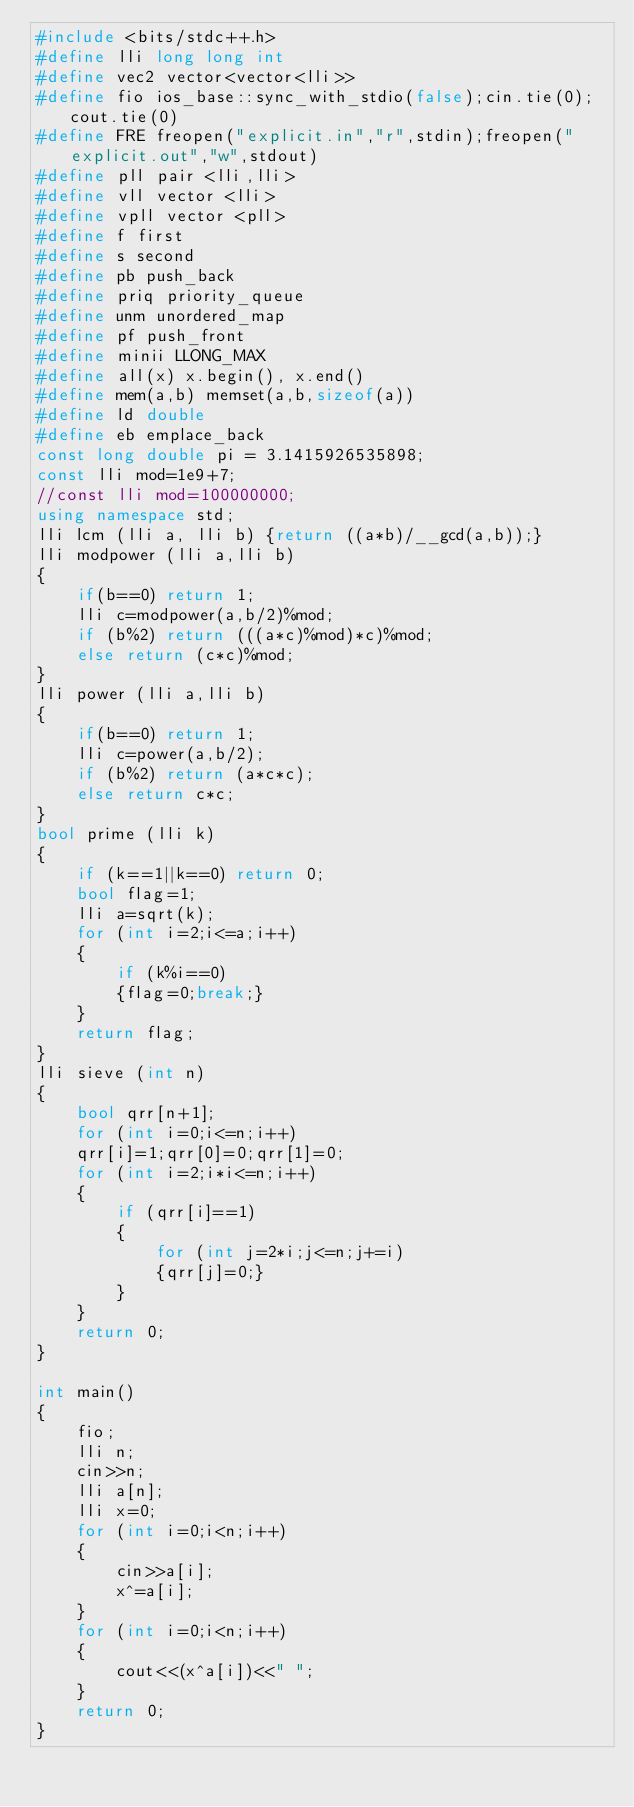Convert code to text. <code><loc_0><loc_0><loc_500><loc_500><_C++_>#include <bits/stdc++.h>
#define lli long long int
#define vec2 vector<vector<lli>>
#define fio ios_base::sync_with_stdio(false);cin.tie(0);cout.tie(0)
#define FRE freopen("explicit.in","r",stdin);freopen("explicit.out","w",stdout)
#define pll pair <lli,lli>
#define vll vector <lli>
#define vpll vector <pll>
#define f first
#define s second
#define pb push_back
#define priq priority_queue
#define unm unordered_map
#define pf push_front
#define minii LLONG_MAX
#define all(x) x.begin(), x.end()
#define mem(a,b) memset(a,b,sizeof(a))
#define ld double
#define eb emplace_back
const long double pi = 3.1415926535898;
const lli mod=1e9+7;
//const lli mod=100000000;
using namespace std;
lli lcm (lli a, lli b) {return ((a*b)/__gcd(a,b));}
lli modpower (lli a,lli b)
{
    if(b==0) return 1;
    lli c=modpower(a,b/2)%mod;
    if (b%2) return (((a*c)%mod)*c)%mod;
    else return (c*c)%mod;
}
lli power (lli a,lli b)
{
    if(b==0) return 1;
    lli c=power(a,b/2);
    if (b%2) return (a*c*c);
    else return c*c;
}
bool prime (lli k)
{
    if (k==1||k==0) return 0;
    bool flag=1;
    lli a=sqrt(k);
    for (int i=2;i<=a;i++)
    {
        if (k%i==0)
        {flag=0;break;}
    }
    return flag;
}
lli sieve (int n)
{
    bool qrr[n+1];
    for (int i=0;i<=n;i++)
    qrr[i]=1;qrr[0]=0;qrr[1]=0;
    for (int i=2;i*i<=n;i++)
    {
        if (qrr[i]==1)
        {
            for (int j=2*i;j<=n;j+=i)
            {qrr[j]=0;}
        }
    }
    return 0;
}

int main()
{
    fio;
    lli n;
    cin>>n;
    lli a[n];
    lli x=0;
    for (int i=0;i<n;i++)
    {
        cin>>a[i];
        x^=a[i];
    }
    for (int i=0;i<n;i++)
    {
        cout<<(x^a[i])<<" ";
    }
    return 0;
}
</code> 